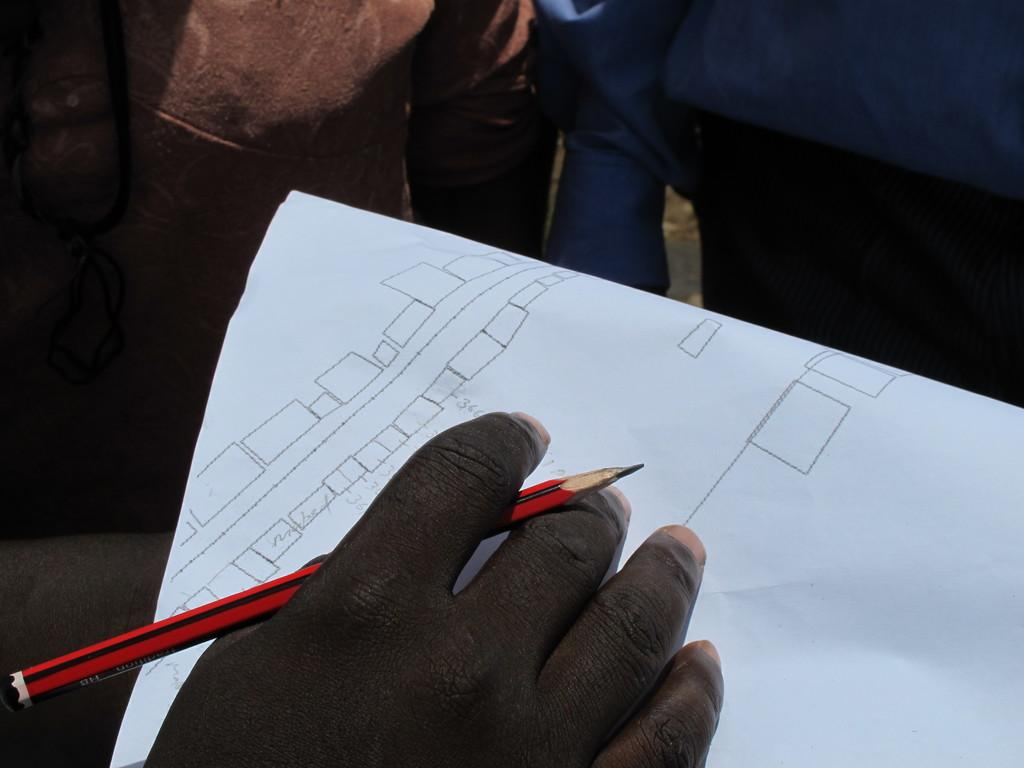What is the person's hand holding in the image? The person's hand is holding a pencil in the image. What is the pencil touching in the image? The pencil is touching a paper in the image. Can you describe the people visible at the top side of the image? Unfortunately, the provided facts do not give any information about the people visible at the top side of the image. What type of fog can be seen in the image? There is no fog present in the image; it only shows a person's hand holding a pencil on a paper. 